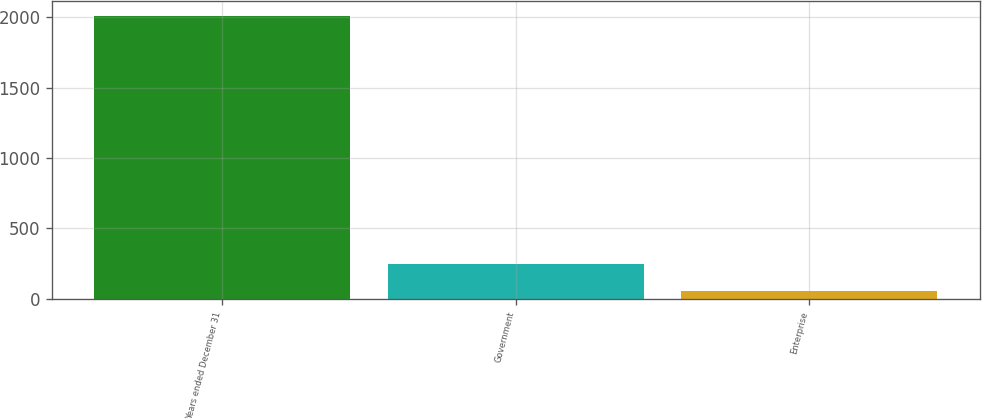Convert chart. <chart><loc_0><loc_0><loc_500><loc_500><bar_chart><fcel>Years ended December 31<fcel>Government<fcel>Enterprise<nl><fcel>2012<fcel>250.7<fcel>55<nl></chart> 